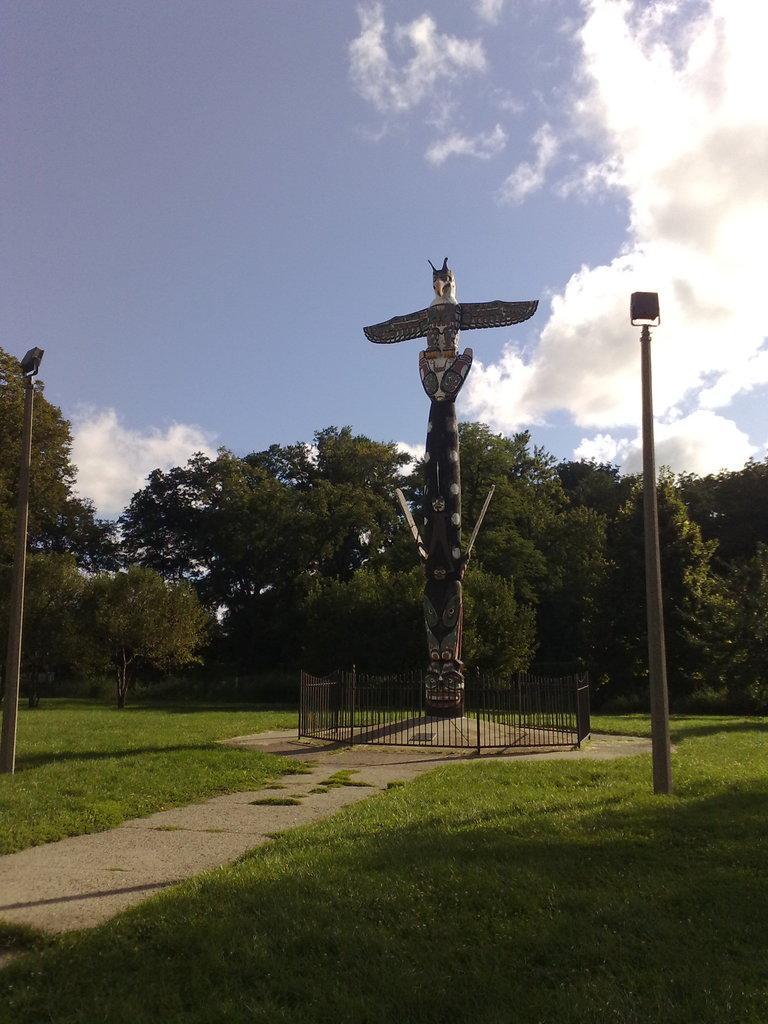Could you give a brief overview of what you see in this image? In this image in the center there is one statue and on the right side and left side there are two poles and lights. At the bottom there is grass and walkway, in the background there are some trees. On the top of the image there is sky. 